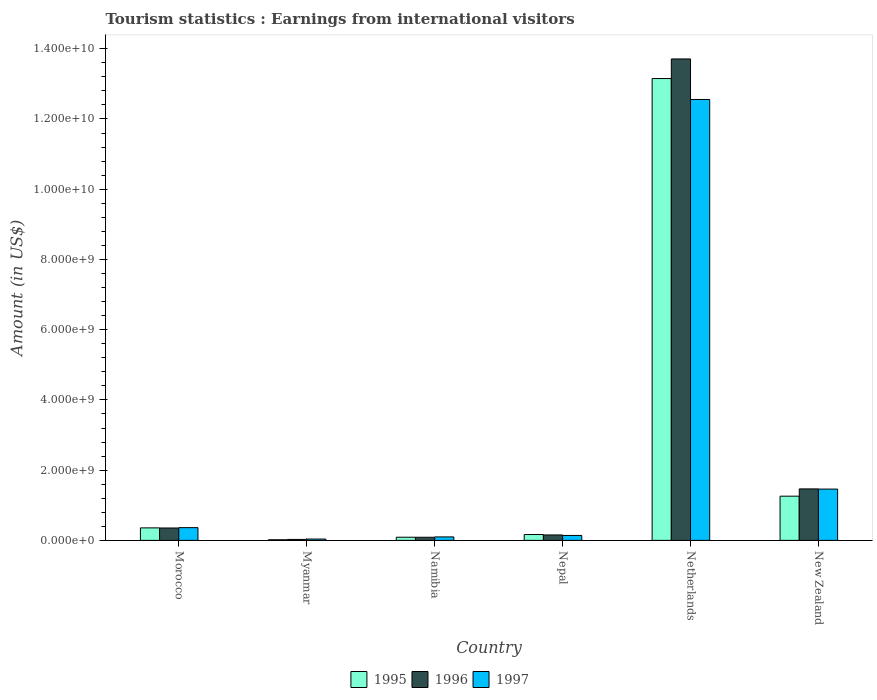How many different coloured bars are there?
Your answer should be compact. 3. How many groups of bars are there?
Make the answer very short. 6. Are the number of bars per tick equal to the number of legend labels?
Offer a very short reply. Yes. Are the number of bars on each tick of the X-axis equal?
Your response must be concise. Yes. How many bars are there on the 4th tick from the left?
Your answer should be compact. 3. How many bars are there on the 2nd tick from the right?
Your response must be concise. 3. What is the label of the 2nd group of bars from the left?
Your response must be concise. Myanmar. In how many cases, is the number of bars for a given country not equal to the number of legend labels?
Keep it short and to the point. 0. What is the earnings from international visitors in 1996 in Nepal?
Your answer should be compact. 1.55e+08. Across all countries, what is the maximum earnings from international visitors in 1997?
Your response must be concise. 1.26e+1. Across all countries, what is the minimum earnings from international visitors in 1996?
Make the answer very short. 2.80e+07. In which country was the earnings from international visitors in 1995 minimum?
Make the answer very short. Myanmar. What is the total earnings from international visitors in 1995 in the graph?
Offer a very short reply. 1.50e+1. What is the difference between the earnings from international visitors in 1997 in Morocco and that in Nepal?
Your answer should be very brief. 2.22e+08. What is the difference between the earnings from international visitors in 1997 in Morocco and the earnings from international visitors in 1995 in Myanmar?
Offer a terse response. 3.45e+08. What is the average earnings from international visitors in 1996 per country?
Your answer should be very brief. 2.63e+09. What is the difference between the earnings from international visitors of/in 1995 and earnings from international visitors of/in 1997 in New Zealand?
Offer a terse response. -2.02e+08. What is the ratio of the earnings from international visitors in 1996 in Myanmar to that in New Zealand?
Your response must be concise. 0.02. Is the difference between the earnings from international visitors in 1995 in Morocco and New Zealand greater than the difference between the earnings from international visitors in 1997 in Morocco and New Zealand?
Your answer should be very brief. Yes. What is the difference between the highest and the second highest earnings from international visitors in 1996?
Your answer should be very brief. 1.34e+1. What is the difference between the highest and the lowest earnings from international visitors in 1996?
Ensure brevity in your answer.  1.37e+1. In how many countries, is the earnings from international visitors in 1995 greater than the average earnings from international visitors in 1995 taken over all countries?
Provide a succinct answer. 1. What does the 2nd bar from the left in Myanmar represents?
Your answer should be compact. 1996. What does the 2nd bar from the right in New Zealand represents?
Your answer should be compact. 1996. Is it the case that in every country, the sum of the earnings from international visitors in 1995 and earnings from international visitors in 1997 is greater than the earnings from international visitors in 1996?
Offer a terse response. Yes. What is the difference between two consecutive major ticks on the Y-axis?
Offer a terse response. 2.00e+09. Are the values on the major ticks of Y-axis written in scientific E-notation?
Your answer should be compact. Yes. Does the graph contain any zero values?
Provide a short and direct response. No. Does the graph contain grids?
Give a very brief answer. No. How many legend labels are there?
Provide a short and direct response. 3. How are the legend labels stacked?
Your answer should be compact. Horizontal. What is the title of the graph?
Make the answer very short. Tourism statistics : Earnings from international visitors. Does "1987" appear as one of the legend labels in the graph?
Make the answer very short. No. What is the label or title of the X-axis?
Your response must be concise. Country. What is the Amount (in US$) of 1995 in Morocco?
Make the answer very short. 3.56e+08. What is the Amount (in US$) of 1996 in Morocco?
Your answer should be very brief. 3.53e+08. What is the Amount (in US$) in 1997 in Morocco?
Keep it short and to the point. 3.63e+08. What is the Amount (in US$) in 1995 in Myanmar?
Your response must be concise. 1.80e+07. What is the Amount (in US$) of 1996 in Myanmar?
Give a very brief answer. 2.80e+07. What is the Amount (in US$) in 1997 in Myanmar?
Ensure brevity in your answer.  3.80e+07. What is the Amount (in US$) of 1995 in Namibia?
Offer a terse response. 9.00e+07. What is the Amount (in US$) in 1996 in Namibia?
Provide a short and direct response. 8.90e+07. What is the Amount (in US$) in 1997 in Namibia?
Keep it short and to the point. 9.90e+07. What is the Amount (in US$) in 1995 in Nepal?
Provide a short and direct response. 1.67e+08. What is the Amount (in US$) of 1996 in Nepal?
Your answer should be very brief. 1.55e+08. What is the Amount (in US$) of 1997 in Nepal?
Offer a terse response. 1.41e+08. What is the Amount (in US$) in 1995 in Netherlands?
Give a very brief answer. 1.32e+1. What is the Amount (in US$) in 1996 in Netherlands?
Keep it short and to the point. 1.37e+1. What is the Amount (in US$) of 1997 in Netherlands?
Offer a terse response. 1.26e+1. What is the Amount (in US$) of 1995 in New Zealand?
Your response must be concise. 1.26e+09. What is the Amount (in US$) in 1996 in New Zealand?
Your answer should be very brief. 1.47e+09. What is the Amount (in US$) in 1997 in New Zealand?
Give a very brief answer. 1.46e+09. Across all countries, what is the maximum Amount (in US$) in 1995?
Give a very brief answer. 1.32e+1. Across all countries, what is the maximum Amount (in US$) in 1996?
Provide a short and direct response. 1.37e+1. Across all countries, what is the maximum Amount (in US$) of 1997?
Offer a terse response. 1.26e+1. Across all countries, what is the minimum Amount (in US$) of 1995?
Ensure brevity in your answer.  1.80e+07. Across all countries, what is the minimum Amount (in US$) of 1996?
Provide a short and direct response. 2.80e+07. Across all countries, what is the minimum Amount (in US$) of 1997?
Your response must be concise. 3.80e+07. What is the total Amount (in US$) in 1995 in the graph?
Your answer should be very brief. 1.50e+1. What is the total Amount (in US$) of 1996 in the graph?
Ensure brevity in your answer.  1.58e+1. What is the total Amount (in US$) of 1997 in the graph?
Make the answer very short. 1.47e+1. What is the difference between the Amount (in US$) of 1995 in Morocco and that in Myanmar?
Give a very brief answer. 3.38e+08. What is the difference between the Amount (in US$) in 1996 in Morocco and that in Myanmar?
Provide a succinct answer. 3.25e+08. What is the difference between the Amount (in US$) of 1997 in Morocco and that in Myanmar?
Offer a very short reply. 3.25e+08. What is the difference between the Amount (in US$) of 1995 in Morocco and that in Namibia?
Your answer should be compact. 2.66e+08. What is the difference between the Amount (in US$) of 1996 in Morocco and that in Namibia?
Your answer should be compact. 2.64e+08. What is the difference between the Amount (in US$) of 1997 in Morocco and that in Namibia?
Your answer should be compact. 2.64e+08. What is the difference between the Amount (in US$) in 1995 in Morocco and that in Nepal?
Keep it short and to the point. 1.89e+08. What is the difference between the Amount (in US$) of 1996 in Morocco and that in Nepal?
Keep it short and to the point. 1.98e+08. What is the difference between the Amount (in US$) of 1997 in Morocco and that in Nepal?
Provide a succinct answer. 2.22e+08. What is the difference between the Amount (in US$) of 1995 in Morocco and that in Netherlands?
Your answer should be compact. -1.28e+1. What is the difference between the Amount (in US$) in 1996 in Morocco and that in Netherlands?
Your response must be concise. -1.34e+1. What is the difference between the Amount (in US$) of 1997 in Morocco and that in Netherlands?
Provide a succinct answer. -1.22e+1. What is the difference between the Amount (in US$) of 1995 in Morocco and that in New Zealand?
Your answer should be compact. -9.03e+08. What is the difference between the Amount (in US$) in 1996 in Morocco and that in New Zealand?
Offer a very short reply. -1.11e+09. What is the difference between the Amount (in US$) in 1997 in Morocco and that in New Zealand?
Provide a short and direct response. -1.10e+09. What is the difference between the Amount (in US$) of 1995 in Myanmar and that in Namibia?
Offer a very short reply. -7.20e+07. What is the difference between the Amount (in US$) in 1996 in Myanmar and that in Namibia?
Give a very brief answer. -6.10e+07. What is the difference between the Amount (in US$) of 1997 in Myanmar and that in Namibia?
Offer a very short reply. -6.10e+07. What is the difference between the Amount (in US$) of 1995 in Myanmar and that in Nepal?
Keep it short and to the point. -1.49e+08. What is the difference between the Amount (in US$) of 1996 in Myanmar and that in Nepal?
Give a very brief answer. -1.27e+08. What is the difference between the Amount (in US$) in 1997 in Myanmar and that in Nepal?
Offer a very short reply. -1.03e+08. What is the difference between the Amount (in US$) of 1995 in Myanmar and that in Netherlands?
Offer a very short reply. -1.31e+1. What is the difference between the Amount (in US$) of 1996 in Myanmar and that in Netherlands?
Make the answer very short. -1.37e+1. What is the difference between the Amount (in US$) of 1997 in Myanmar and that in Netherlands?
Provide a short and direct response. -1.25e+1. What is the difference between the Amount (in US$) in 1995 in Myanmar and that in New Zealand?
Offer a terse response. -1.24e+09. What is the difference between the Amount (in US$) of 1996 in Myanmar and that in New Zealand?
Provide a succinct answer. -1.44e+09. What is the difference between the Amount (in US$) in 1997 in Myanmar and that in New Zealand?
Keep it short and to the point. -1.42e+09. What is the difference between the Amount (in US$) in 1995 in Namibia and that in Nepal?
Your answer should be compact. -7.70e+07. What is the difference between the Amount (in US$) in 1996 in Namibia and that in Nepal?
Ensure brevity in your answer.  -6.60e+07. What is the difference between the Amount (in US$) of 1997 in Namibia and that in Nepal?
Your answer should be compact. -4.20e+07. What is the difference between the Amount (in US$) in 1995 in Namibia and that in Netherlands?
Make the answer very short. -1.31e+1. What is the difference between the Amount (in US$) in 1996 in Namibia and that in Netherlands?
Offer a terse response. -1.36e+1. What is the difference between the Amount (in US$) of 1997 in Namibia and that in Netherlands?
Provide a short and direct response. -1.25e+1. What is the difference between the Amount (in US$) of 1995 in Namibia and that in New Zealand?
Your response must be concise. -1.17e+09. What is the difference between the Amount (in US$) of 1996 in Namibia and that in New Zealand?
Your response must be concise. -1.38e+09. What is the difference between the Amount (in US$) in 1997 in Namibia and that in New Zealand?
Provide a short and direct response. -1.36e+09. What is the difference between the Amount (in US$) of 1995 in Nepal and that in Netherlands?
Your response must be concise. -1.30e+1. What is the difference between the Amount (in US$) of 1996 in Nepal and that in Netherlands?
Keep it short and to the point. -1.36e+1. What is the difference between the Amount (in US$) of 1997 in Nepal and that in Netherlands?
Give a very brief answer. -1.24e+1. What is the difference between the Amount (in US$) of 1995 in Nepal and that in New Zealand?
Your answer should be very brief. -1.09e+09. What is the difference between the Amount (in US$) of 1996 in Nepal and that in New Zealand?
Offer a very short reply. -1.31e+09. What is the difference between the Amount (in US$) in 1997 in Nepal and that in New Zealand?
Your response must be concise. -1.32e+09. What is the difference between the Amount (in US$) in 1995 in Netherlands and that in New Zealand?
Your answer should be very brief. 1.19e+1. What is the difference between the Amount (in US$) of 1996 in Netherlands and that in New Zealand?
Keep it short and to the point. 1.22e+1. What is the difference between the Amount (in US$) of 1997 in Netherlands and that in New Zealand?
Provide a short and direct response. 1.11e+1. What is the difference between the Amount (in US$) of 1995 in Morocco and the Amount (in US$) of 1996 in Myanmar?
Your answer should be very brief. 3.28e+08. What is the difference between the Amount (in US$) in 1995 in Morocco and the Amount (in US$) in 1997 in Myanmar?
Your answer should be very brief. 3.18e+08. What is the difference between the Amount (in US$) in 1996 in Morocco and the Amount (in US$) in 1997 in Myanmar?
Your response must be concise. 3.15e+08. What is the difference between the Amount (in US$) in 1995 in Morocco and the Amount (in US$) in 1996 in Namibia?
Your answer should be compact. 2.67e+08. What is the difference between the Amount (in US$) in 1995 in Morocco and the Amount (in US$) in 1997 in Namibia?
Your answer should be very brief. 2.57e+08. What is the difference between the Amount (in US$) of 1996 in Morocco and the Amount (in US$) of 1997 in Namibia?
Keep it short and to the point. 2.54e+08. What is the difference between the Amount (in US$) of 1995 in Morocco and the Amount (in US$) of 1996 in Nepal?
Your response must be concise. 2.01e+08. What is the difference between the Amount (in US$) in 1995 in Morocco and the Amount (in US$) in 1997 in Nepal?
Keep it short and to the point. 2.15e+08. What is the difference between the Amount (in US$) of 1996 in Morocco and the Amount (in US$) of 1997 in Nepal?
Make the answer very short. 2.12e+08. What is the difference between the Amount (in US$) in 1995 in Morocco and the Amount (in US$) in 1996 in Netherlands?
Ensure brevity in your answer.  -1.34e+1. What is the difference between the Amount (in US$) of 1995 in Morocco and the Amount (in US$) of 1997 in Netherlands?
Provide a short and direct response. -1.22e+1. What is the difference between the Amount (in US$) in 1996 in Morocco and the Amount (in US$) in 1997 in Netherlands?
Keep it short and to the point. -1.22e+1. What is the difference between the Amount (in US$) in 1995 in Morocco and the Amount (in US$) in 1996 in New Zealand?
Your response must be concise. -1.11e+09. What is the difference between the Amount (in US$) in 1995 in Morocco and the Amount (in US$) in 1997 in New Zealand?
Ensure brevity in your answer.  -1.10e+09. What is the difference between the Amount (in US$) of 1996 in Morocco and the Amount (in US$) of 1997 in New Zealand?
Your answer should be compact. -1.11e+09. What is the difference between the Amount (in US$) in 1995 in Myanmar and the Amount (in US$) in 1996 in Namibia?
Your response must be concise. -7.10e+07. What is the difference between the Amount (in US$) of 1995 in Myanmar and the Amount (in US$) of 1997 in Namibia?
Provide a short and direct response. -8.10e+07. What is the difference between the Amount (in US$) of 1996 in Myanmar and the Amount (in US$) of 1997 in Namibia?
Ensure brevity in your answer.  -7.10e+07. What is the difference between the Amount (in US$) of 1995 in Myanmar and the Amount (in US$) of 1996 in Nepal?
Give a very brief answer. -1.37e+08. What is the difference between the Amount (in US$) in 1995 in Myanmar and the Amount (in US$) in 1997 in Nepal?
Keep it short and to the point. -1.23e+08. What is the difference between the Amount (in US$) of 1996 in Myanmar and the Amount (in US$) of 1997 in Nepal?
Give a very brief answer. -1.13e+08. What is the difference between the Amount (in US$) of 1995 in Myanmar and the Amount (in US$) of 1996 in Netherlands?
Provide a short and direct response. -1.37e+1. What is the difference between the Amount (in US$) in 1995 in Myanmar and the Amount (in US$) in 1997 in Netherlands?
Provide a succinct answer. -1.25e+1. What is the difference between the Amount (in US$) in 1996 in Myanmar and the Amount (in US$) in 1997 in Netherlands?
Your response must be concise. -1.25e+1. What is the difference between the Amount (in US$) of 1995 in Myanmar and the Amount (in US$) of 1996 in New Zealand?
Offer a very short reply. -1.45e+09. What is the difference between the Amount (in US$) in 1995 in Myanmar and the Amount (in US$) in 1997 in New Zealand?
Offer a terse response. -1.44e+09. What is the difference between the Amount (in US$) in 1996 in Myanmar and the Amount (in US$) in 1997 in New Zealand?
Your response must be concise. -1.43e+09. What is the difference between the Amount (in US$) in 1995 in Namibia and the Amount (in US$) in 1996 in Nepal?
Offer a very short reply. -6.50e+07. What is the difference between the Amount (in US$) in 1995 in Namibia and the Amount (in US$) in 1997 in Nepal?
Your answer should be very brief. -5.10e+07. What is the difference between the Amount (in US$) in 1996 in Namibia and the Amount (in US$) in 1997 in Nepal?
Provide a succinct answer. -5.20e+07. What is the difference between the Amount (in US$) of 1995 in Namibia and the Amount (in US$) of 1996 in Netherlands?
Provide a short and direct response. -1.36e+1. What is the difference between the Amount (in US$) in 1995 in Namibia and the Amount (in US$) in 1997 in Netherlands?
Your answer should be compact. -1.25e+1. What is the difference between the Amount (in US$) in 1996 in Namibia and the Amount (in US$) in 1997 in Netherlands?
Provide a short and direct response. -1.25e+1. What is the difference between the Amount (in US$) of 1995 in Namibia and the Amount (in US$) of 1996 in New Zealand?
Your response must be concise. -1.38e+09. What is the difference between the Amount (in US$) of 1995 in Namibia and the Amount (in US$) of 1997 in New Zealand?
Provide a succinct answer. -1.37e+09. What is the difference between the Amount (in US$) of 1996 in Namibia and the Amount (in US$) of 1997 in New Zealand?
Ensure brevity in your answer.  -1.37e+09. What is the difference between the Amount (in US$) in 1995 in Nepal and the Amount (in US$) in 1996 in Netherlands?
Your answer should be compact. -1.35e+1. What is the difference between the Amount (in US$) of 1995 in Nepal and the Amount (in US$) of 1997 in Netherlands?
Provide a succinct answer. -1.24e+1. What is the difference between the Amount (in US$) in 1996 in Nepal and the Amount (in US$) in 1997 in Netherlands?
Offer a terse response. -1.24e+1. What is the difference between the Amount (in US$) of 1995 in Nepal and the Amount (in US$) of 1996 in New Zealand?
Your answer should be very brief. -1.30e+09. What is the difference between the Amount (in US$) of 1995 in Nepal and the Amount (in US$) of 1997 in New Zealand?
Provide a short and direct response. -1.29e+09. What is the difference between the Amount (in US$) in 1996 in Nepal and the Amount (in US$) in 1997 in New Zealand?
Make the answer very short. -1.31e+09. What is the difference between the Amount (in US$) in 1995 in Netherlands and the Amount (in US$) in 1996 in New Zealand?
Give a very brief answer. 1.17e+1. What is the difference between the Amount (in US$) of 1995 in Netherlands and the Amount (in US$) of 1997 in New Zealand?
Offer a very short reply. 1.17e+1. What is the difference between the Amount (in US$) of 1996 in Netherlands and the Amount (in US$) of 1997 in New Zealand?
Ensure brevity in your answer.  1.22e+1. What is the average Amount (in US$) in 1995 per country?
Your answer should be compact. 2.51e+09. What is the average Amount (in US$) in 1996 per country?
Provide a short and direct response. 2.63e+09. What is the average Amount (in US$) in 1997 per country?
Give a very brief answer. 2.44e+09. What is the difference between the Amount (in US$) in 1995 and Amount (in US$) in 1996 in Morocco?
Your answer should be very brief. 3.00e+06. What is the difference between the Amount (in US$) in 1995 and Amount (in US$) in 1997 in Morocco?
Offer a very short reply. -7.00e+06. What is the difference between the Amount (in US$) of 1996 and Amount (in US$) of 1997 in Morocco?
Your answer should be compact. -1.00e+07. What is the difference between the Amount (in US$) in 1995 and Amount (in US$) in 1996 in Myanmar?
Your answer should be compact. -1.00e+07. What is the difference between the Amount (in US$) in 1995 and Amount (in US$) in 1997 in Myanmar?
Your response must be concise. -2.00e+07. What is the difference between the Amount (in US$) in 1996 and Amount (in US$) in 1997 in Myanmar?
Offer a very short reply. -1.00e+07. What is the difference between the Amount (in US$) of 1995 and Amount (in US$) of 1996 in Namibia?
Ensure brevity in your answer.  1.00e+06. What is the difference between the Amount (in US$) in 1995 and Amount (in US$) in 1997 in Namibia?
Make the answer very short. -9.00e+06. What is the difference between the Amount (in US$) in 1996 and Amount (in US$) in 1997 in Namibia?
Ensure brevity in your answer.  -1.00e+07. What is the difference between the Amount (in US$) in 1995 and Amount (in US$) in 1997 in Nepal?
Offer a very short reply. 2.60e+07. What is the difference between the Amount (in US$) in 1996 and Amount (in US$) in 1997 in Nepal?
Provide a succinct answer. 1.40e+07. What is the difference between the Amount (in US$) in 1995 and Amount (in US$) in 1996 in Netherlands?
Ensure brevity in your answer.  -5.58e+08. What is the difference between the Amount (in US$) in 1995 and Amount (in US$) in 1997 in Netherlands?
Your answer should be very brief. 5.96e+08. What is the difference between the Amount (in US$) of 1996 and Amount (in US$) of 1997 in Netherlands?
Ensure brevity in your answer.  1.15e+09. What is the difference between the Amount (in US$) of 1995 and Amount (in US$) of 1996 in New Zealand?
Your response must be concise. -2.07e+08. What is the difference between the Amount (in US$) in 1995 and Amount (in US$) in 1997 in New Zealand?
Ensure brevity in your answer.  -2.02e+08. What is the ratio of the Amount (in US$) in 1995 in Morocco to that in Myanmar?
Offer a terse response. 19.78. What is the ratio of the Amount (in US$) in 1996 in Morocco to that in Myanmar?
Keep it short and to the point. 12.61. What is the ratio of the Amount (in US$) of 1997 in Morocco to that in Myanmar?
Offer a very short reply. 9.55. What is the ratio of the Amount (in US$) of 1995 in Morocco to that in Namibia?
Offer a very short reply. 3.96. What is the ratio of the Amount (in US$) of 1996 in Morocco to that in Namibia?
Your answer should be compact. 3.97. What is the ratio of the Amount (in US$) in 1997 in Morocco to that in Namibia?
Offer a very short reply. 3.67. What is the ratio of the Amount (in US$) in 1995 in Morocco to that in Nepal?
Keep it short and to the point. 2.13. What is the ratio of the Amount (in US$) of 1996 in Morocco to that in Nepal?
Make the answer very short. 2.28. What is the ratio of the Amount (in US$) in 1997 in Morocco to that in Nepal?
Make the answer very short. 2.57. What is the ratio of the Amount (in US$) in 1995 in Morocco to that in Netherlands?
Make the answer very short. 0.03. What is the ratio of the Amount (in US$) of 1996 in Morocco to that in Netherlands?
Give a very brief answer. 0.03. What is the ratio of the Amount (in US$) in 1997 in Morocco to that in Netherlands?
Provide a succinct answer. 0.03. What is the ratio of the Amount (in US$) of 1995 in Morocco to that in New Zealand?
Ensure brevity in your answer.  0.28. What is the ratio of the Amount (in US$) in 1996 in Morocco to that in New Zealand?
Make the answer very short. 0.24. What is the ratio of the Amount (in US$) of 1997 in Morocco to that in New Zealand?
Your response must be concise. 0.25. What is the ratio of the Amount (in US$) of 1996 in Myanmar to that in Namibia?
Provide a succinct answer. 0.31. What is the ratio of the Amount (in US$) of 1997 in Myanmar to that in Namibia?
Provide a succinct answer. 0.38. What is the ratio of the Amount (in US$) of 1995 in Myanmar to that in Nepal?
Offer a terse response. 0.11. What is the ratio of the Amount (in US$) in 1996 in Myanmar to that in Nepal?
Provide a short and direct response. 0.18. What is the ratio of the Amount (in US$) in 1997 in Myanmar to that in Nepal?
Your answer should be very brief. 0.27. What is the ratio of the Amount (in US$) in 1995 in Myanmar to that in Netherlands?
Offer a very short reply. 0. What is the ratio of the Amount (in US$) of 1996 in Myanmar to that in Netherlands?
Keep it short and to the point. 0. What is the ratio of the Amount (in US$) of 1997 in Myanmar to that in Netherlands?
Offer a terse response. 0. What is the ratio of the Amount (in US$) in 1995 in Myanmar to that in New Zealand?
Provide a succinct answer. 0.01. What is the ratio of the Amount (in US$) in 1996 in Myanmar to that in New Zealand?
Your answer should be very brief. 0.02. What is the ratio of the Amount (in US$) in 1997 in Myanmar to that in New Zealand?
Offer a terse response. 0.03. What is the ratio of the Amount (in US$) of 1995 in Namibia to that in Nepal?
Provide a succinct answer. 0.54. What is the ratio of the Amount (in US$) in 1996 in Namibia to that in Nepal?
Ensure brevity in your answer.  0.57. What is the ratio of the Amount (in US$) in 1997 in Namibia to that in Nepal?
Your answer should be very brief. 0.7. What is the ratio of the Amount (in US$) of 1995 in Namibia to that in Netherlands?
Provide a short and direct response. 0.01. What is the ratio of the Amount (in US$) of 1996 in Namibia to that in Netherlands?
Your response must be concise. 0.01. What is the ratio of the Amount (in US$) of 1997 in Namibia to that in Netherlands?
Your answer should be compact. 0.01. What is the ratio of the Amount (in US$) in 1995 in Namibia to that in New Zealand?
Your response must be concise. 0.07. What is the ratio of the Amount (in US$) in 1996 in Namibia to that in New Zealand?
Offer a very short reply. 0.06. What is the ratio of the Amount (in US$) of 1997 in Namibia to that in New Zealand?
Your answer should be compact. 0.07. What is the ratio of the Amount (in US$) in 1995 in Nepal to that in Netherlands?
Your answer should be compact. 0.01. What is the ratio of the Amount (in US$) in 1996 in Nepal to that in Netherlands?
Give a very brief answer. 0.01. What is the ratio of the Amount (in US$) of 1997 in Nepal to that in Netherlands?
Your answer should be compact. 0.01. What is the ratio of the Amount (in US$) of 1995 in Nepal to that in New Zealand?
Keep it short and to the point. 0.13. What is the ratio of the Amount (in US$) of 1996 in Nepal to that in New Zealand?
Keep it short and to the point. 0.11. What is the ratio of the Amount (in US$) of 1997 in Nepal to that in New Zealand?
Offer a terse response. 0.1. What is the ratio of the Amount (in US$) of 1995 in Netherlands to that in New Zealand?
Provide a succinct answer. 10.45. What is the ratio of the Amount (in US$) in 1996 in Netherlands to that in New Zealand?
Make the answer very short. 9.35. What is the ratio of the Amount (in US$) of 1997 in Netherlands to that in New Zealand?
Provide a succinct answer. 8.59. What is the difference between the highest and the second highest Amount (in US$) in 1995?
Make the answer very short. 1.19e+1. What is the difference between the highest and the second highest Amount (in US$) of 1996?
Offer a terse response. 1.22e+1. What is the difference between the highest and the second highest Amount (in US$) in 1997?
Your answer should be compact. 1.11e+1. What is the difference between the highest and the lowest Amount (in US$) in 1995?
Your response must be concise. 1.31e+1. What is the difference between the highest and the lowest Amount (in US$) of 1996?
Make the answer very short. 1.37e+1. What is the difference between the highest and the lowest Amount (in US$) in 1997?
Keep it short and to the point. 1.25e+1. 